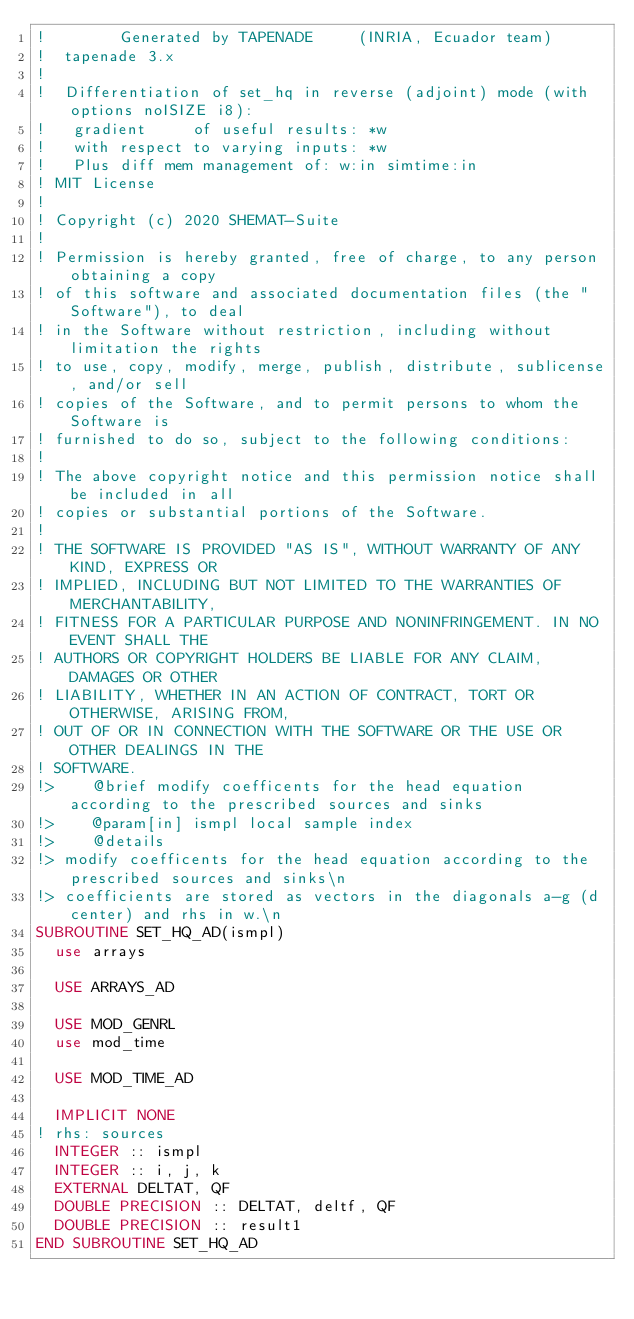Convert code to text. <code><loc_0><loc_0><loc_500><loc_500><_FORTRAN_>!        Generated by TAPENADE     (INRIA, Ecuador team)
!  tapenade 3.x
!
!  Differentiation of set_hq in reverse (adjoint) mode (with options noISIZE i8):
!   gradient     of useful results: *w
!   with respect to varying inputs: *w
!   Plus diff mem management of: w:in simtime:in
! MIT License
!
! Copyright (c) 2020 SHEMAT-Suite
!
! Permission is hereby granted, free of charge, to any person obtaining a copy
! of this software and associated documentation files (the "Software"), to deal
! in the Software without restriction, including without limitation the rights
! to use, copy, modify, merge, publish, distribute, sublicense, and/or sell
! copies of the Software, and to permit persons to whom the Software is
! furnished to do so, subject to the following conditions:
!
! The above copyright notice and this permission notice shall be included in all
! copies or substantial portions of the Software.
!
! THE SOFTWARE IS PROVIDED "AS IS", WITHOUT WARRANTY OF ANY KIND, EXPRESS OR
! IMPLIED, INCLUDING BUT NOT LIMITED TO THE WARRANTIES OF MERCHANTABILITY,
! FITNESS FOR A PARTICULAR PURPOSE AND NONINFRINGEMENT. IN NO EVENT SHALL THE
! AUTHORS OR COPYRIGHT HOLDERS BE LIABLE FOR ANY CLAIM, DAMAGES OR OTHER
! LIABILITY, WHETHER IN AN ACTION OF CONTRACT, TORT OR OTHERWISE, ARISING FROM,
! OUT OF OR IN CONNECTION WITH THE SOFTWARE OR THE USE OR OTHER DEALINGS IN THE
! SOFTWARE.
!>    @brief modify coefficents for the head equation according to the prescribed sources and sinks
!>    @param[in] ismpl local sample index
!>    @details
!> modify coefficents for the head equation according to the prescribed sources and sinks\n
!> coefficients are stored as vectors in the diagonals a-g (d center) and rhs in w.\n
SUBROUTINE SET_HQ_AD(ismpl)
  use arrays

  USE ARRAYS_AD

  USE MOD_GENRL
  use mod_time

  USE MOD_TIME_AD

  IMPLICIT NONE
! rhs: sources
  INTEGER :: ismpl
  INTEGER :: i, j, k
  EXTERNAL DELTAT, QF
  DOUBLE PRECISION :: DELTAT, deltf, QF
  DOUBLE PRECISION :: result1
END SUBROUTINE SET_HQ_AD

</code> 